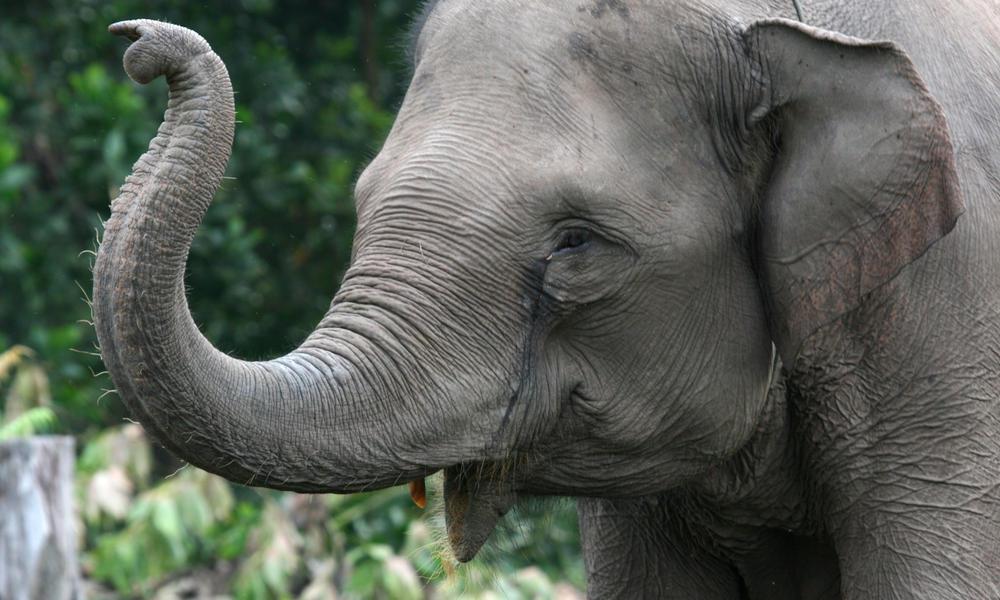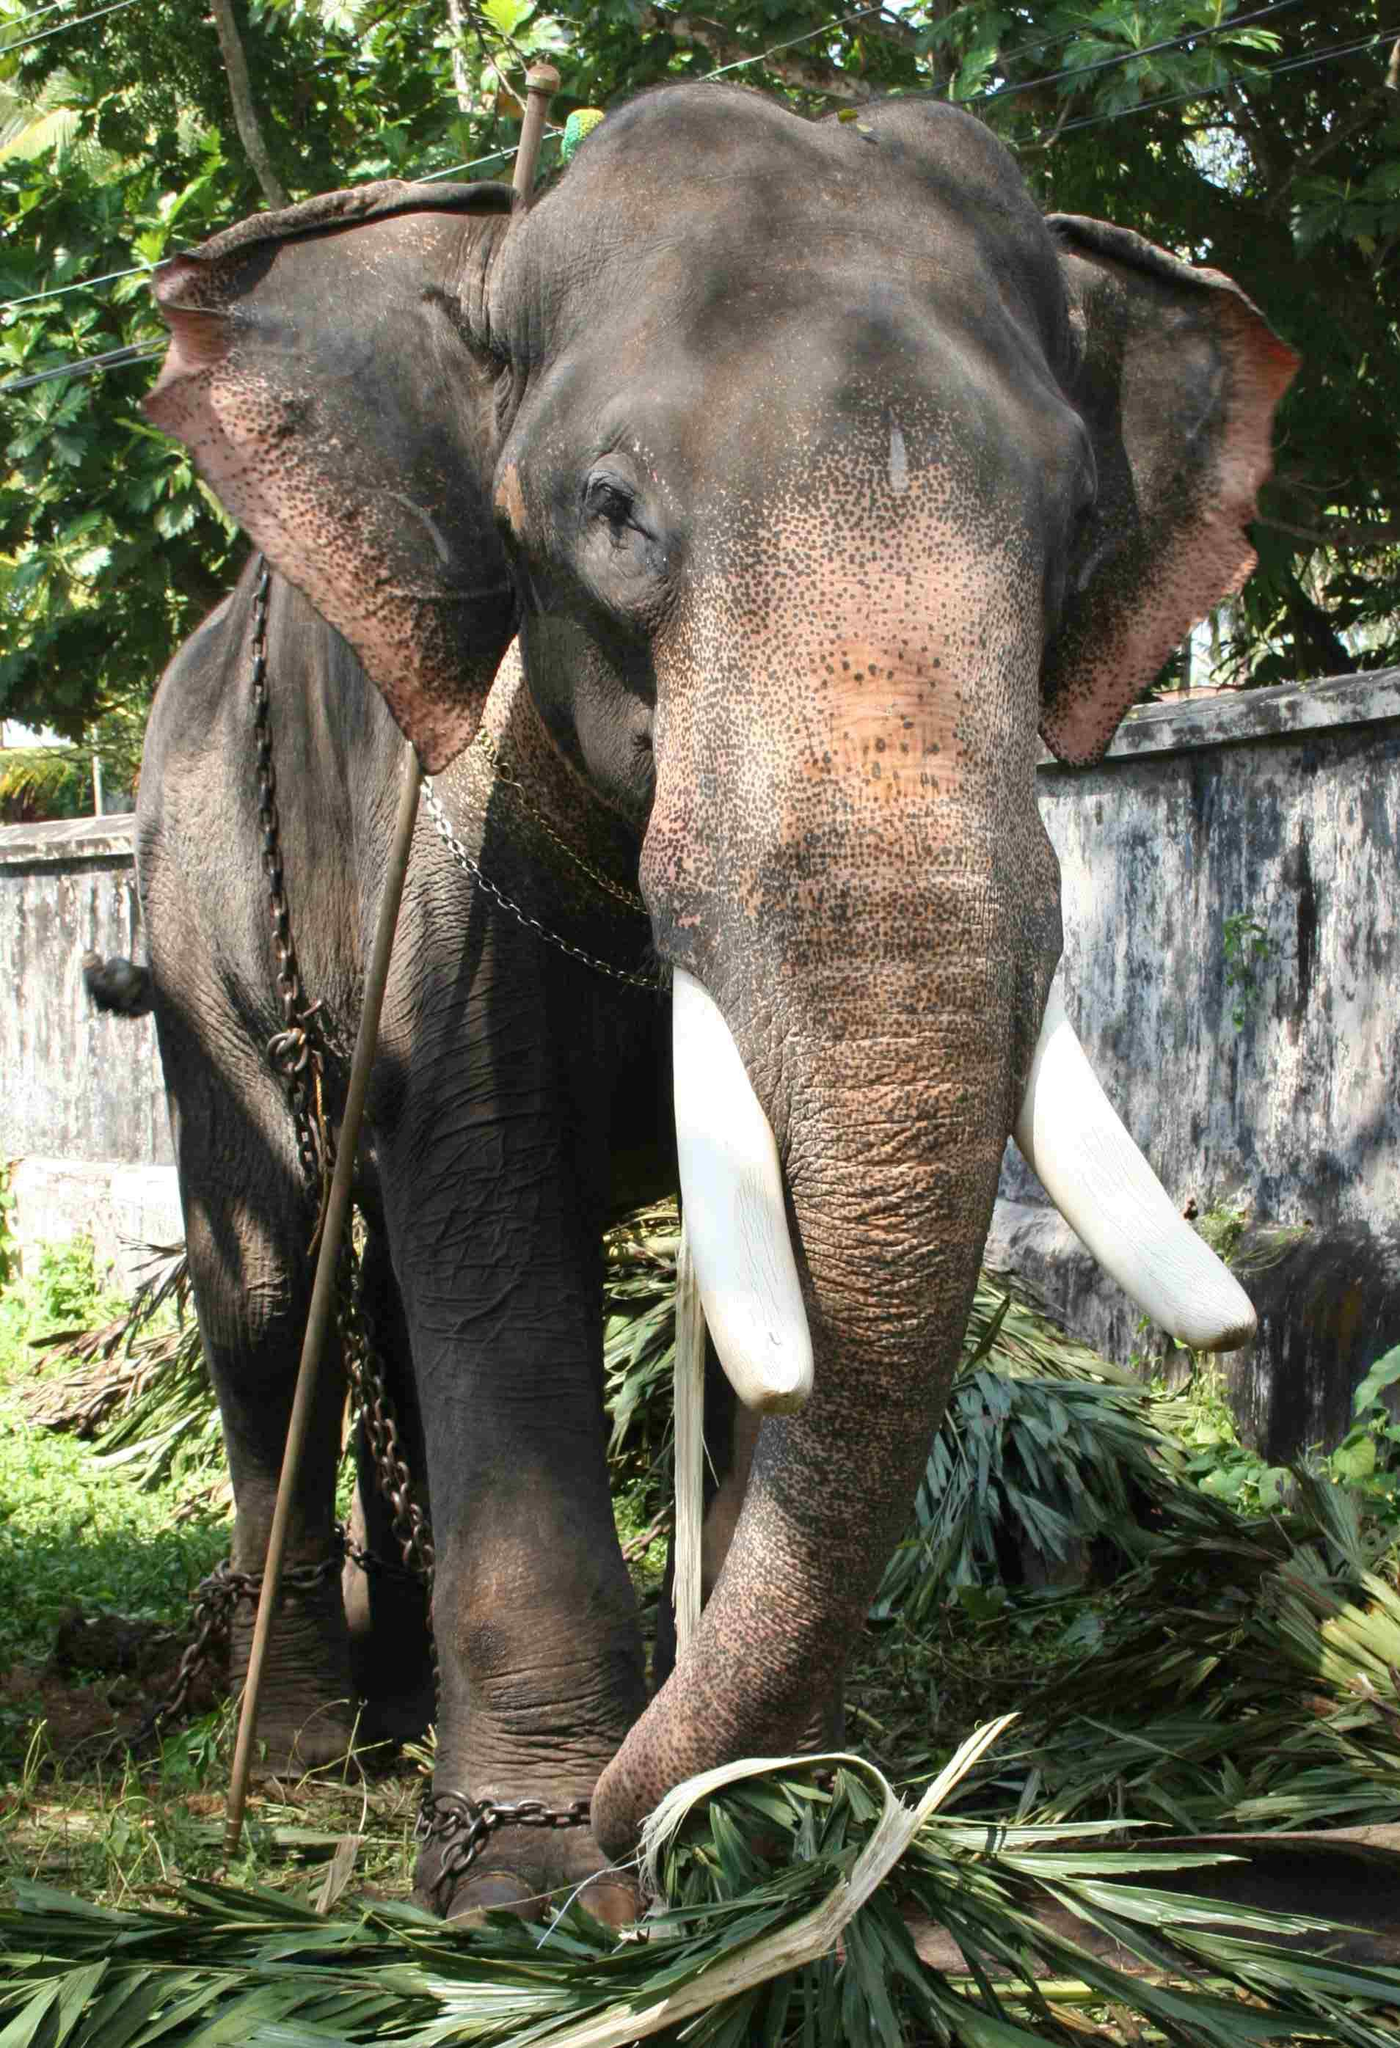The first image is the image on the left, the second image is the image on the right. Assess this claim about the two images: "An enclosure is seen behind one of the elephants.". Correct or not? Answer yes or no. Yes. The first image is the image on the left, the second image is the image on the right. Given the left and right images, does the statement "An image shows a young elephant standing next to at least one adult elephant." hold true? Answer yes or no. No. 